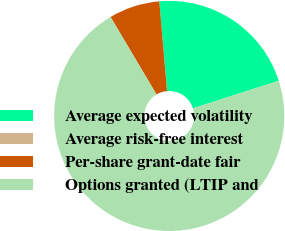Convert chart to OTSL. <chart><loc_0><loc_0><loc_500><loc_500><pie_chart><fcel>Average expected volatility<fcel>Average risk-free interest<fcel>Per-share grant-date fair<fcel>Options granted (LTIP and<nl><fcel>21.43%<fcel>0.0%<fcel>7.14%<fcel>71.43%<nl></chart> 